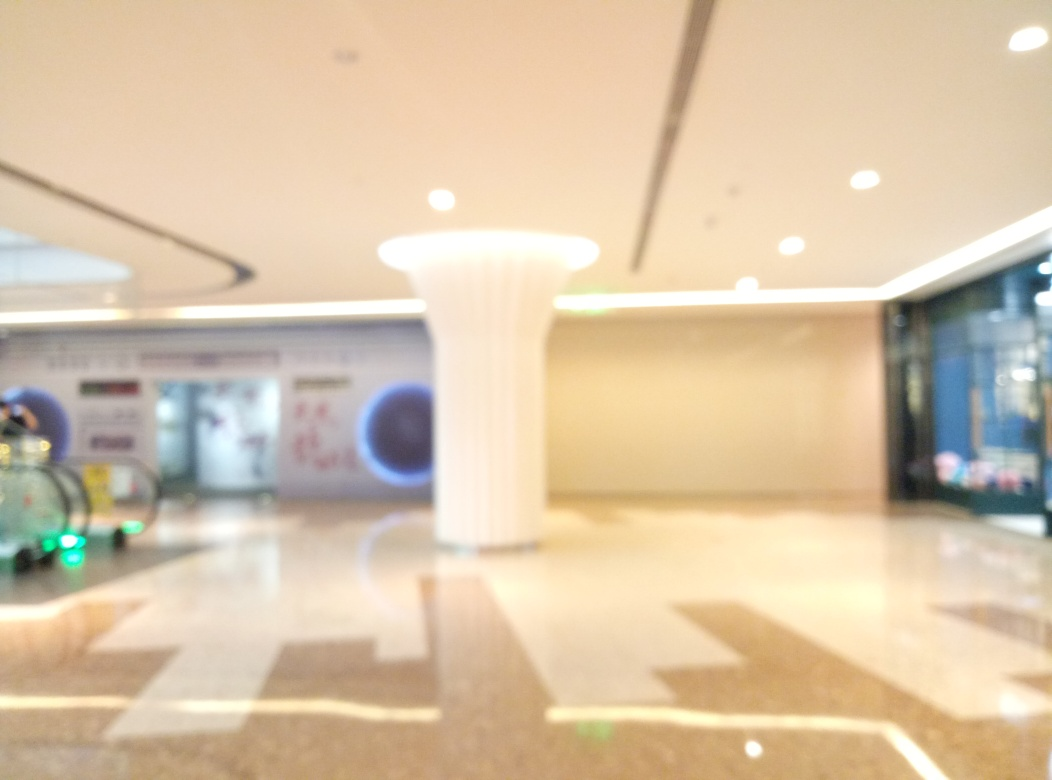Can you talk about the aesthetics and design elements observed here? Despite the blurriness of the image, some design elements can be noted. The floor has geometric patterns, which add to the visual interest. The column appears to be stylized with a fluted design, hinting at an architectural influence, maybe neoclassical or modern reinterpretation. The overall aesthetic feels open and contemporary, with minimal clutter and a focus on open space. 